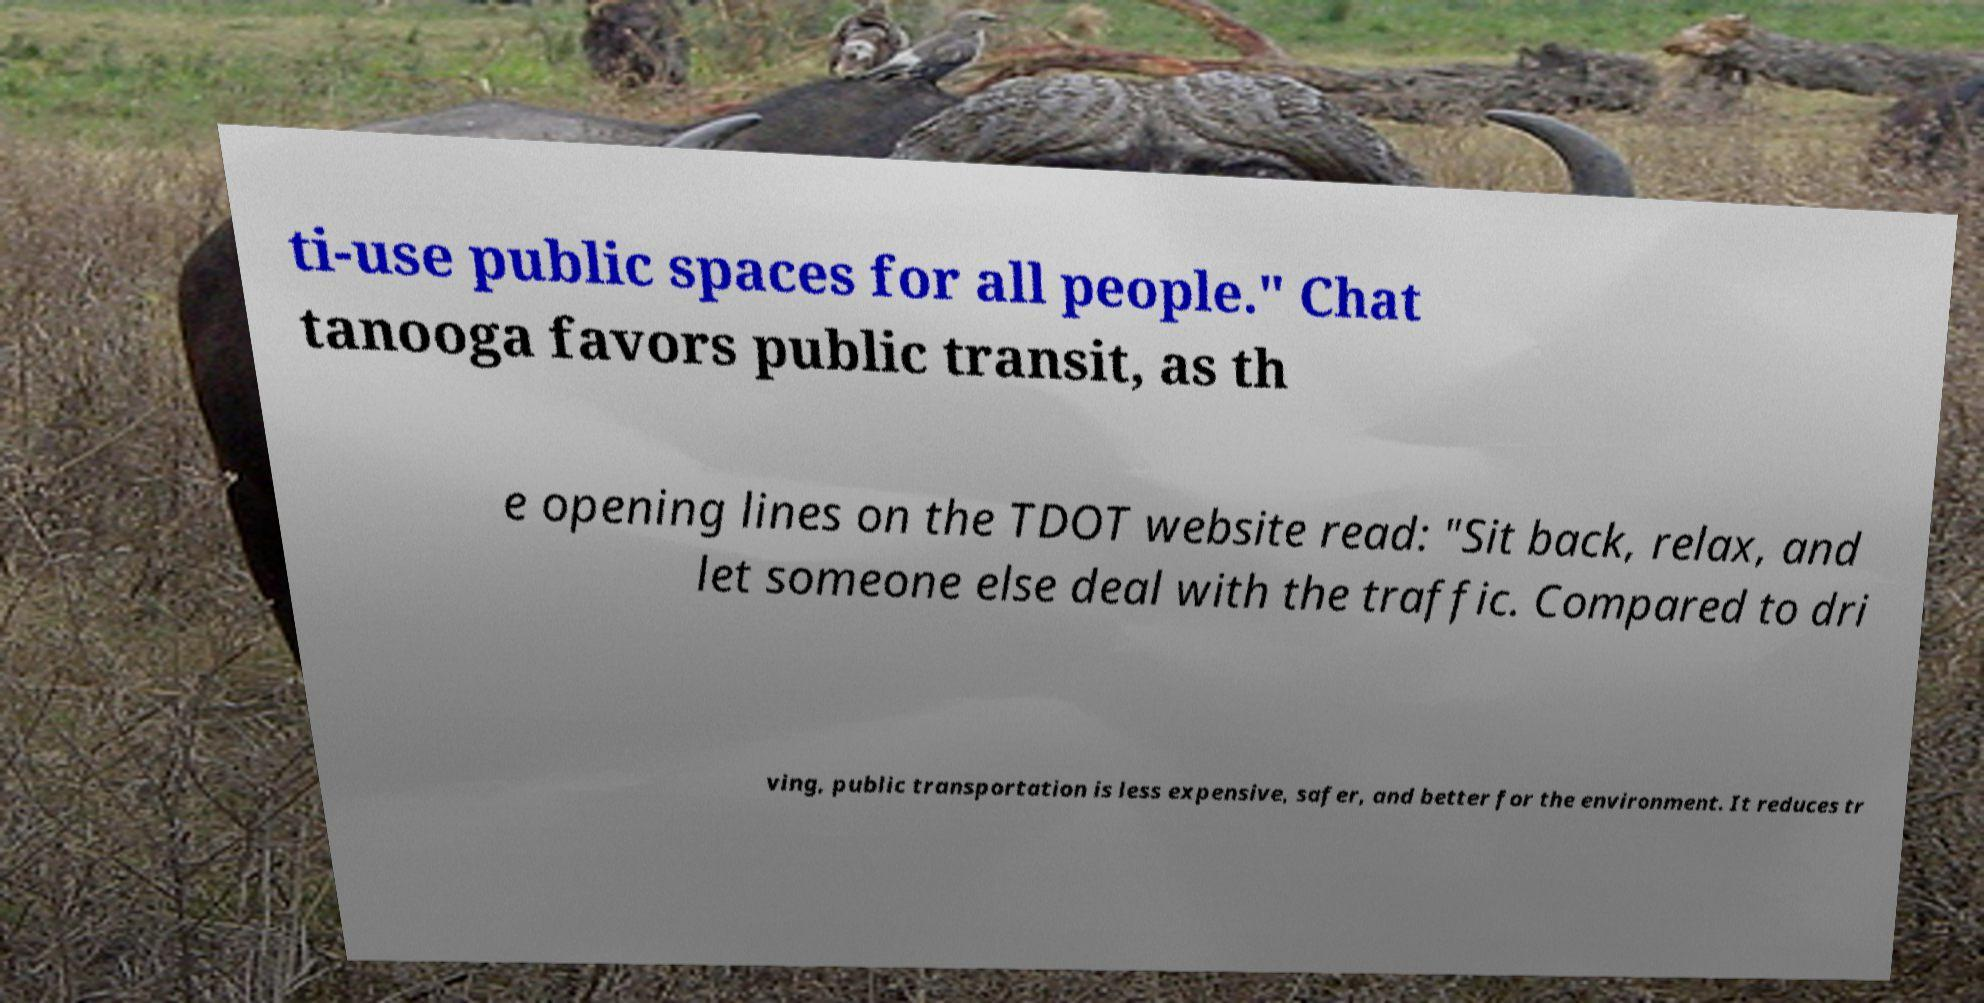For documentation purposes, I need the text within this image transcribed. Could you provide that? ti-use public spaces for all people." Chat tanooga favors public transit, as th e opening lines on the TDOT website read: "Sit back, relax, and let someone else deal with the traffic. Compared to dri ving, public transportation is less expensive, safer, and better for the environment. It reduces tr 